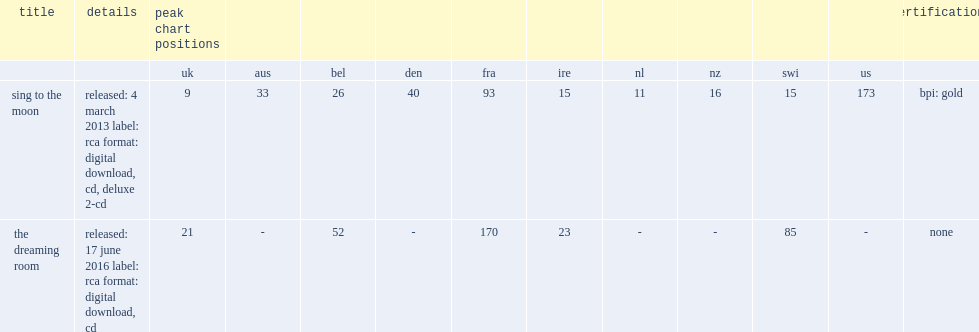What was the peak chart position on the uk albums chart of sing to the moon? 9.0. 